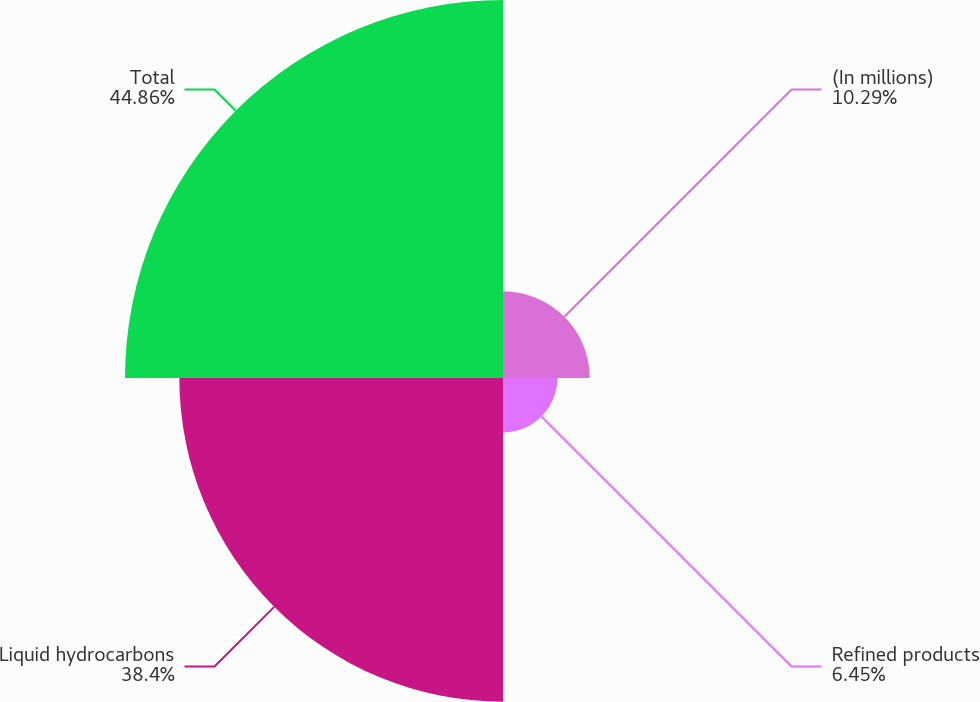Convert chart. <chart><loc_0><loc_0><loc_500><loc_500><pie_chart><fcel>(In millions)<fcel>Refined products<fcel>Liquid hydrocarbons<fcel>Total<nl><fcel>10.29%<fcel>6.45%<fcel>38.4%<fcel>44.85%<nl></chart> 